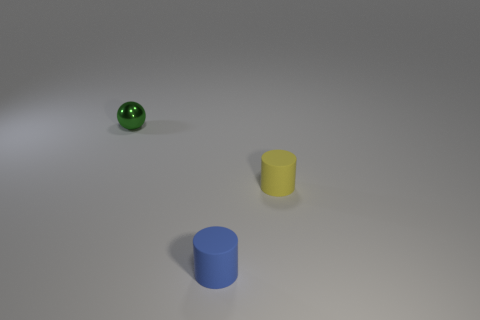Add 3 small yellow metal things. How many objects exist? 6 Subtract all cylinders. How many objects are left? 1 Subtract all yellow cylinders. How many cylinders are left? 1 Subtract 1 balls. How many balls are left? 0 Add 3 small yellow matte objects. How many small yellow matte objects are left? 4 Add 2 tiny green metal things. How many tiny green metal things exist? 3 Subtract 0 blue blocks. How many objects are left? 3 Subtract all blue balls. Subtract all purple cubes. How many balls are left? 1 Subtract all brown cylinders. How many cyan spheres are left? 0 Subtract all green spheres. Subtract all green shiny balls. How many objects are left? 1 